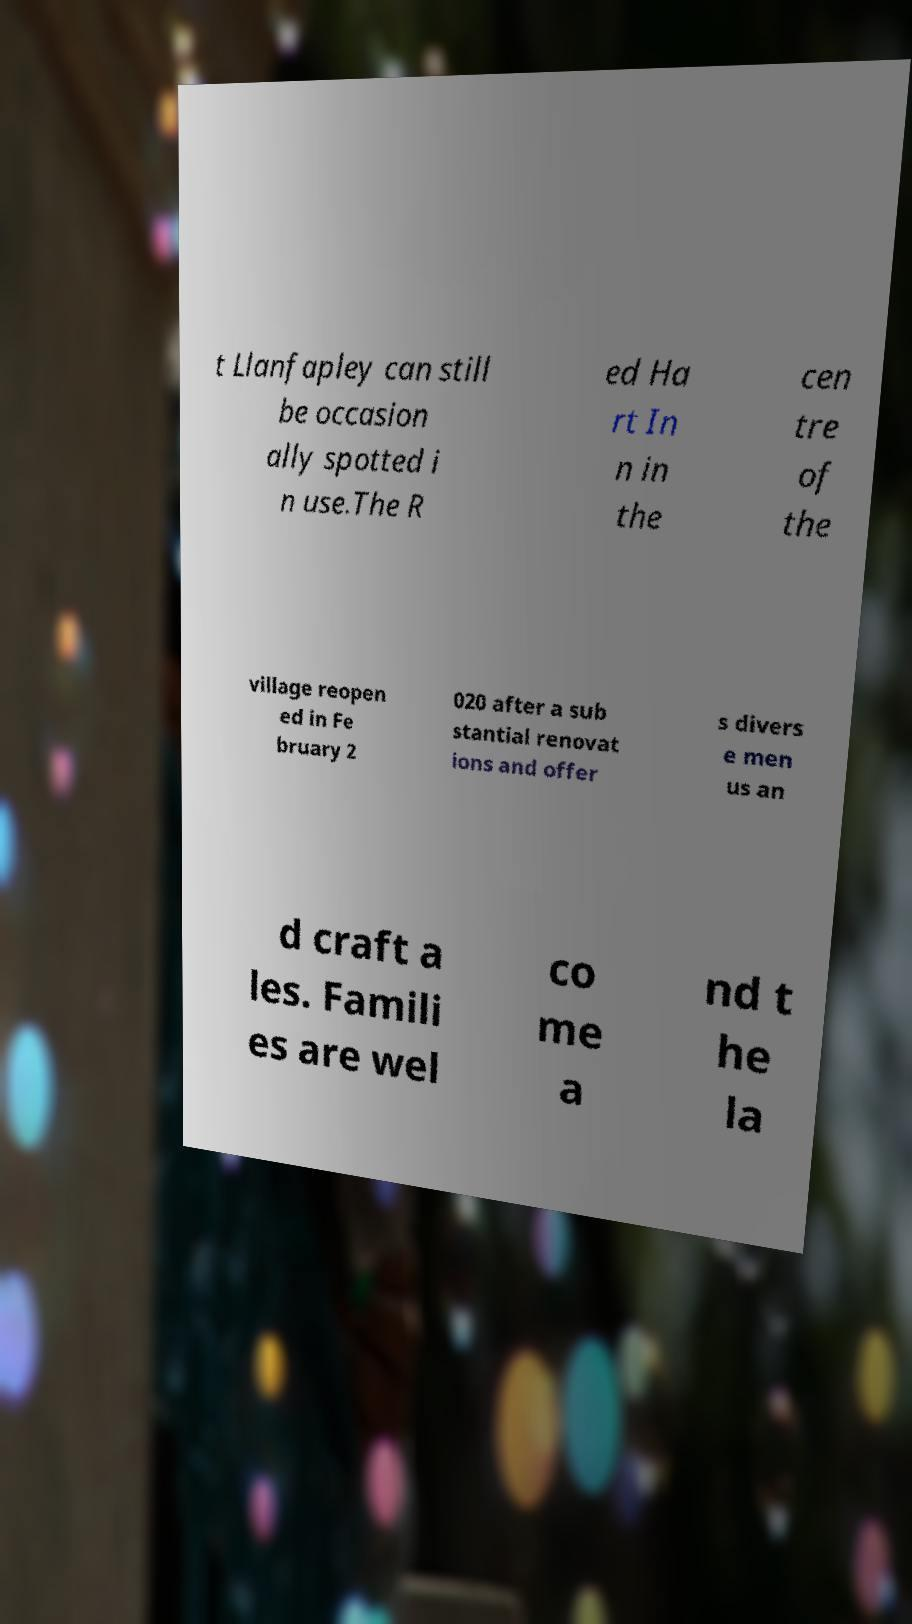Could you extract and type out the text from this image? t Llanfapley can still be occasion ally spotted i n use.The R ed Ha rt In n in the cen tre of the village reopen ed in Fe bruary 2 020 after a sub stantial renovat ions and offer s divers e men us an d craft a les. Famili es are wel co me a nd t he la 